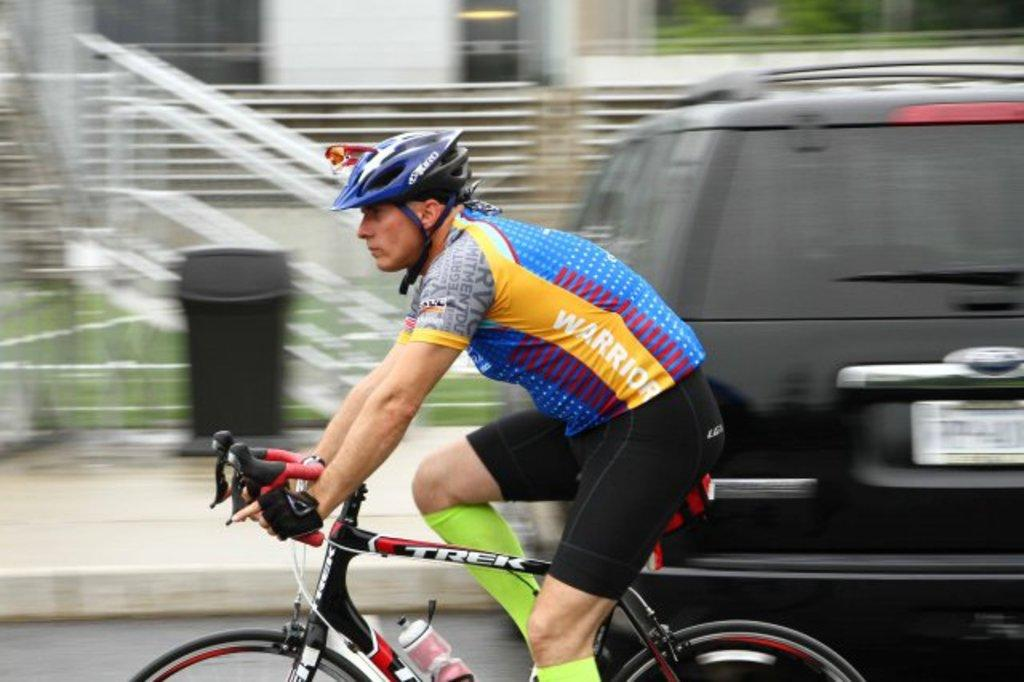What is the person doing in the image? The person is riding a bicycle. Can you describe the mode of transportation the person is using? The person is on a bicycle. What other vehicle is present in the image? There is a car in the image. What type of rail can be seen supporting the stem of the bicycle in the image? There is no rail or stem present in the image; it features a person riding a bicycle and a car. 